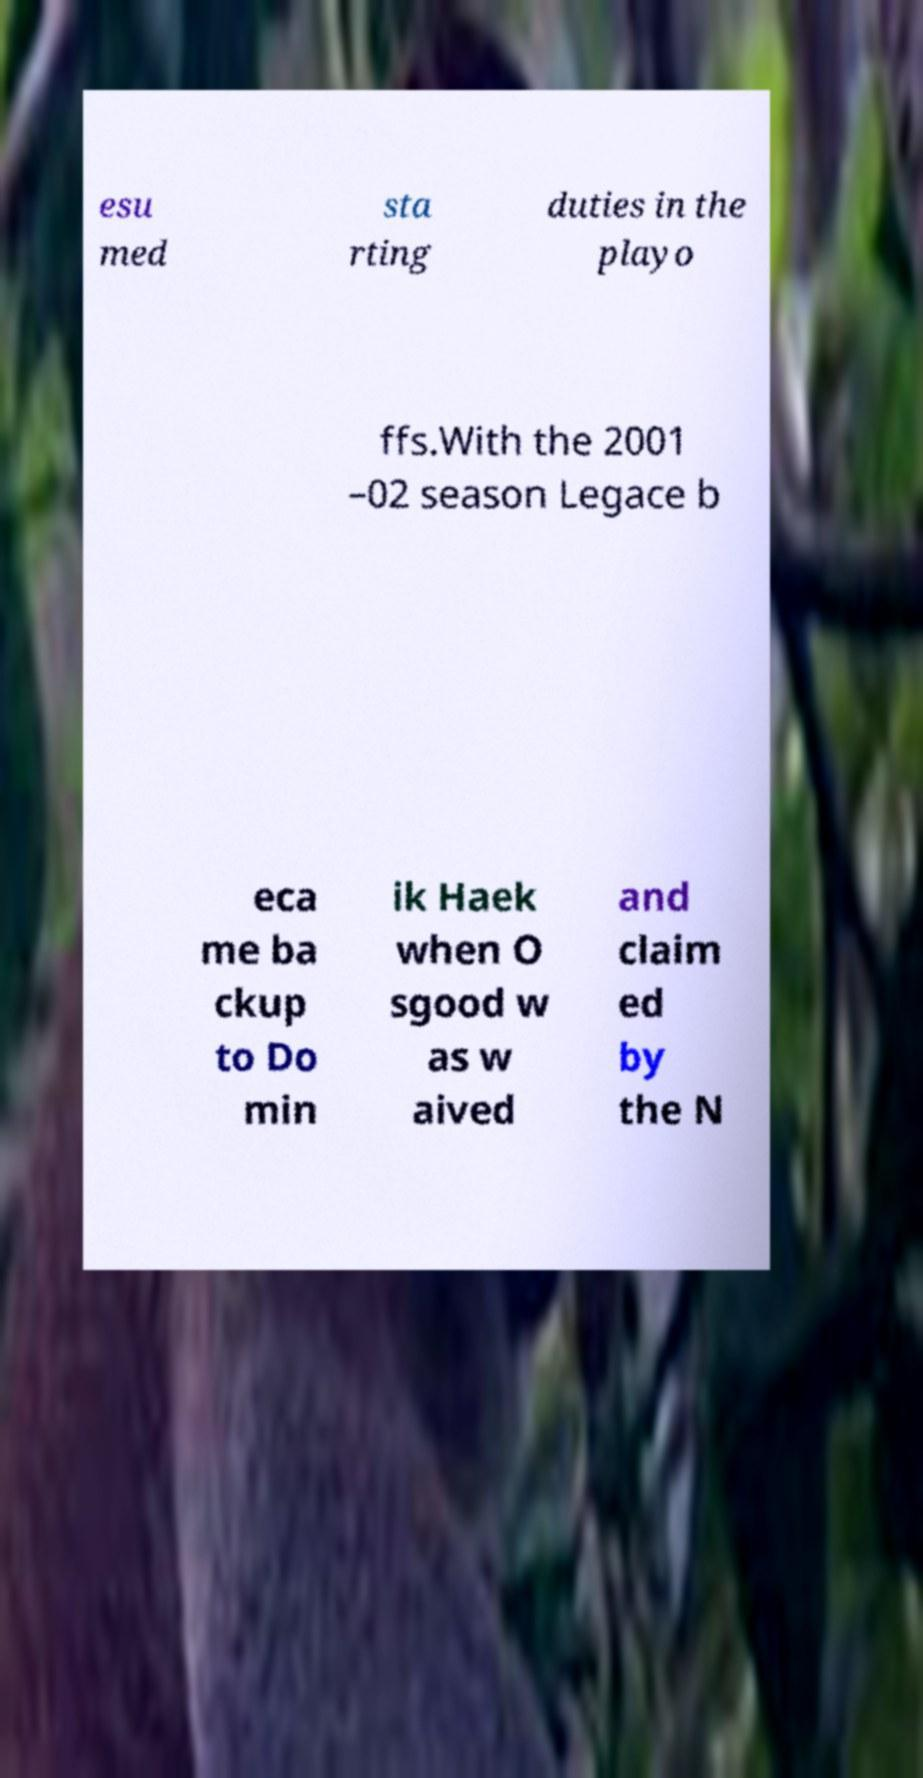Could you assist in decoding the text presented in this image and type it out clearly? esu med sta rting duties in the playo ffs.With the 2001 –02 season Legace b eca me ba ckup to Do min ik Haek when O sgood w as w aived and claim ed by the N 